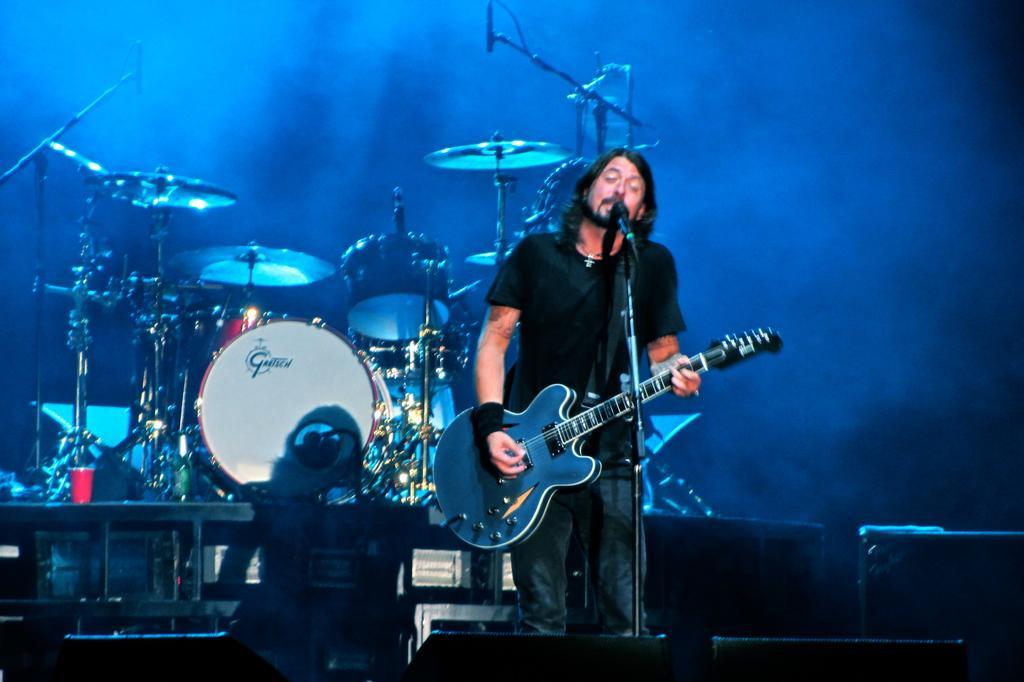Can you describe this image briefly? In the picture we can see a man standing and singing a song near the microphone and holding a guitar which is blue in color, a man is wearing a black T-shirt, in the background we can see a orchestra systems and a blue shade with smoke. 